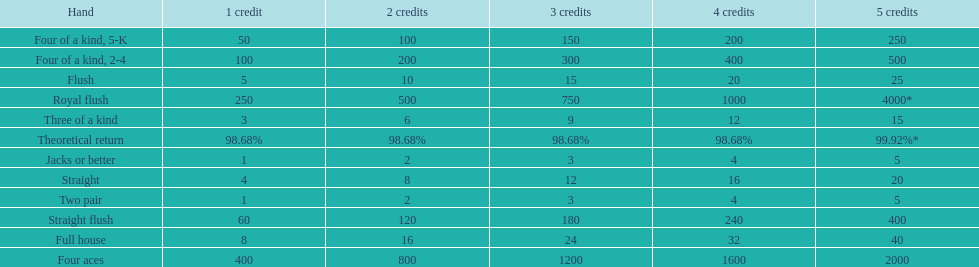The number of flush wins at one credit to equal one flush win at 5 credits. 5. Can you parse all the data within this table? {'header': ['Hand', '1 credit', '2 credits', '3 credits', '4 credits', '5 credits'], 'rows': [['Four of a kind, 5-K', '50', '100', '150', '200', '250'], ['Four of a kind, 2-4', '100', '200', '300', '400', '500'], ['Flush', '5', '10', '15', '20', '25'], ['Royal flush', '250', '500', '750', '1000', '4000*'], ['Three of a kind', '3', '6', '9', '12', '15'], ['Theoretical return', '98.68%', '98.68%', '98.68%', '98.68%', '99.92%*'], ['Jacks or better', '1', '2', '3', '4', '5'], ['Straight', '4', '8', '12', '16', '20'], ['Two pair', '1', '2', '3', '4', '5'], ['Straight flush', '60', '120', '180', '240', '400'], ['Full house', '8', '16', '24', '32', '40'], ['Four aces', '400', '800', '1200', '1600', '2000']]} 